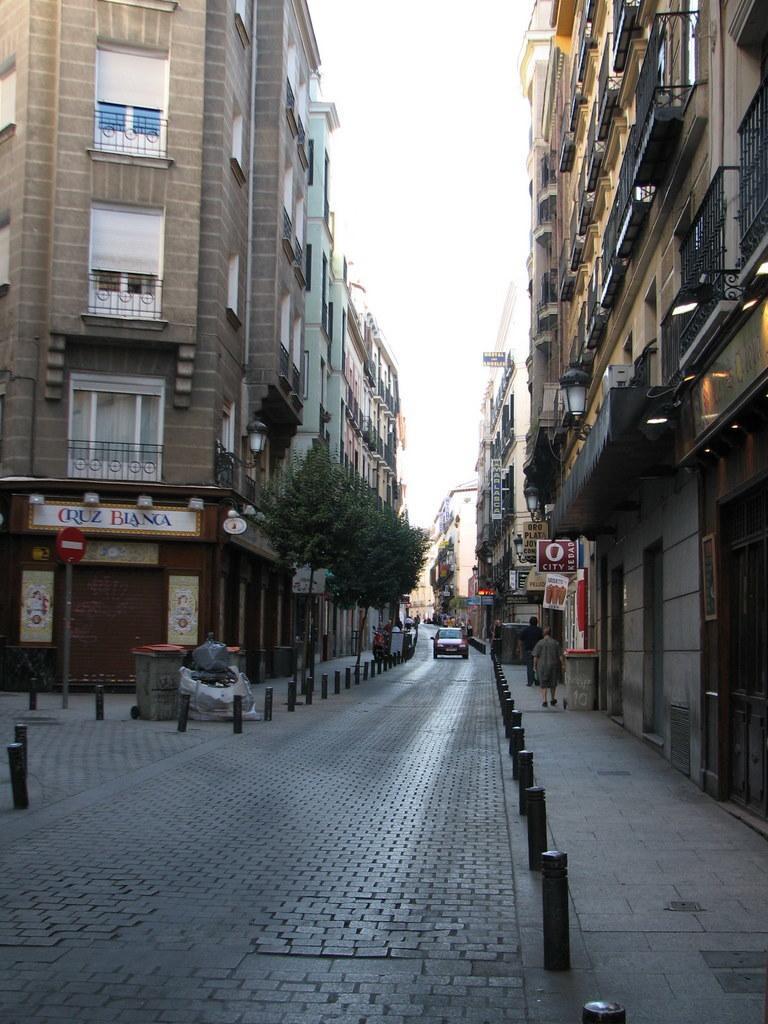Please provide a concise description of this image. In this image we can see bin, vehicle, people, sign boards, trees, boards, buildings, rods and sky. Lights are attached to the wall. 